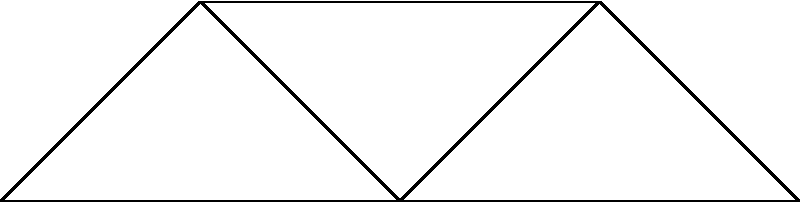A fast-food delivery service in your city uses the network shown above to connect its restaurants (R1 to R5). The numbers on the edges represent the delivery time in minutes between restaurants. What is the minimum time required to deliver food from R1 to R5 while passing through at least one other restaurant? To solve this problem, we need to find the shortest path from R1 to R5 that includes at least one other restaurant. Let's break it down step-by-step:

1. Identify all possible paths from R1 to R5 passing through at least one other restaurant:
   a) R1 -> R2 -> R3 -> R4 -> R5
   b) R1 -> R2 -> R3 -> R5
   c) R1 -> R3 -> R4 -> R5
   d) R1 -> R3 -> R5

2. Calculate the total time for each path:
   a) R1 -> R2 -> R3 -> R4 -> R5 = 5 + 3 + 4 + 2 = 14 minutes
   b) R1 -> R2 -> R3 -> R5 = 5 + 3 + 7 = 15 minutes
   c) R1 -> R3 -> R4 -> R5 = 6 + 4 + 2 = 12 minutes
   d) R1 -> R3 -> R5 = 6 + 7 = 13 minutes

3. Compare the total times:
   The shortest time is 12 minutes, which corresponds to path c) R1 -> R3 -> R4 -> R5.

Therefore, the minimum time required to deliver food from R1 to R5 while passing through at least one other restaurant is 12 minutes.
Answer: 12 minutes 